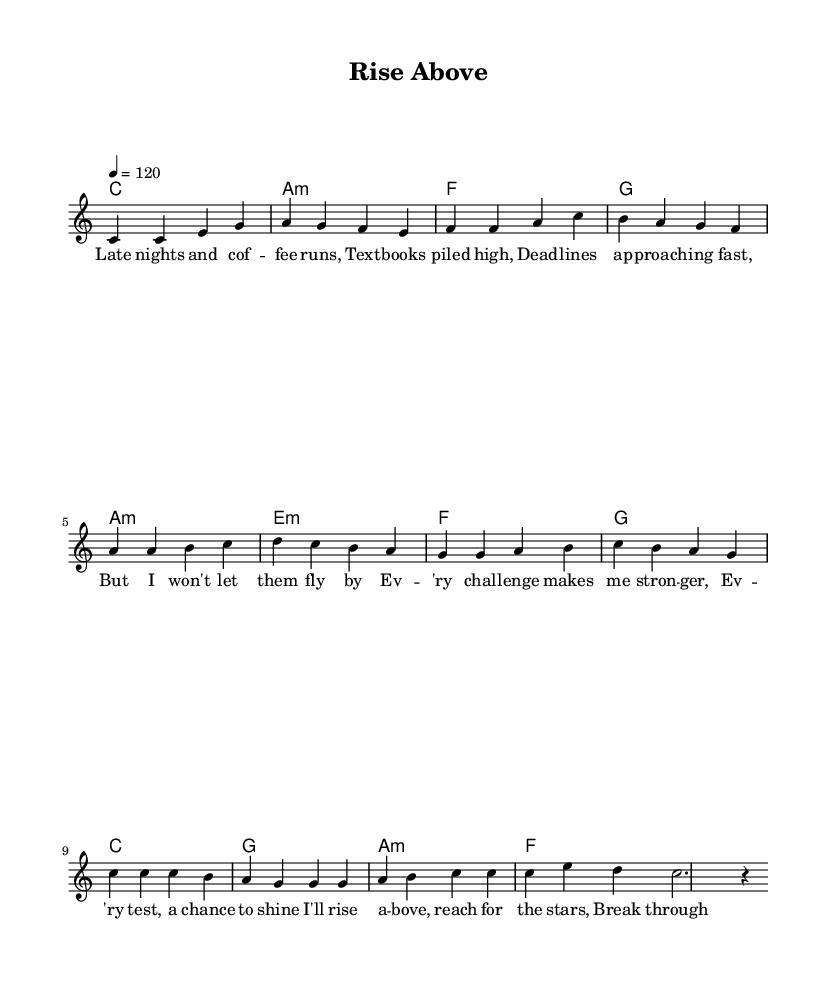What is the key signature of this music? The key signature is indicated at the beginning of the score, which shows one flat and therefore signifies the key of C major.
Answer: C major What is the time signature of the piece? The time signature is displayed at the beginning of the sheet music, indicating that there are four beats in each measure.
Answer: 4/4 What is the tempo marking for the music? The tempo marking is shown in the score indicating that the quarter note is to be played at a speed of 120 beats per minute.
Answer: 120 How many measures are in the chorus? To find the number of measures in the chorus, I look at the section labeled "Chorus" and count the musical phrases; there are four measures in total.
Answer: 4 What is the first chord of the verse? The chords are listed in conjunction with the melody; the first chord accompanying the verse is C major.
Answer: C major What feeling does the pre-chorus evoke based on the lyrics? Analyzing the lyrics of the pre-chorus, it emphasizes strength and empowerment, suggesting a positive and uplifting emotional tone.
Answer: Stronger How do the lyrical themes support the pop genre? The lyrics focus on overcoming challenges and personal growth, common themes in pop music that resonate with listeners and create anthemic songs leading to widespread appeal.
Answer: Overcoming challenges 